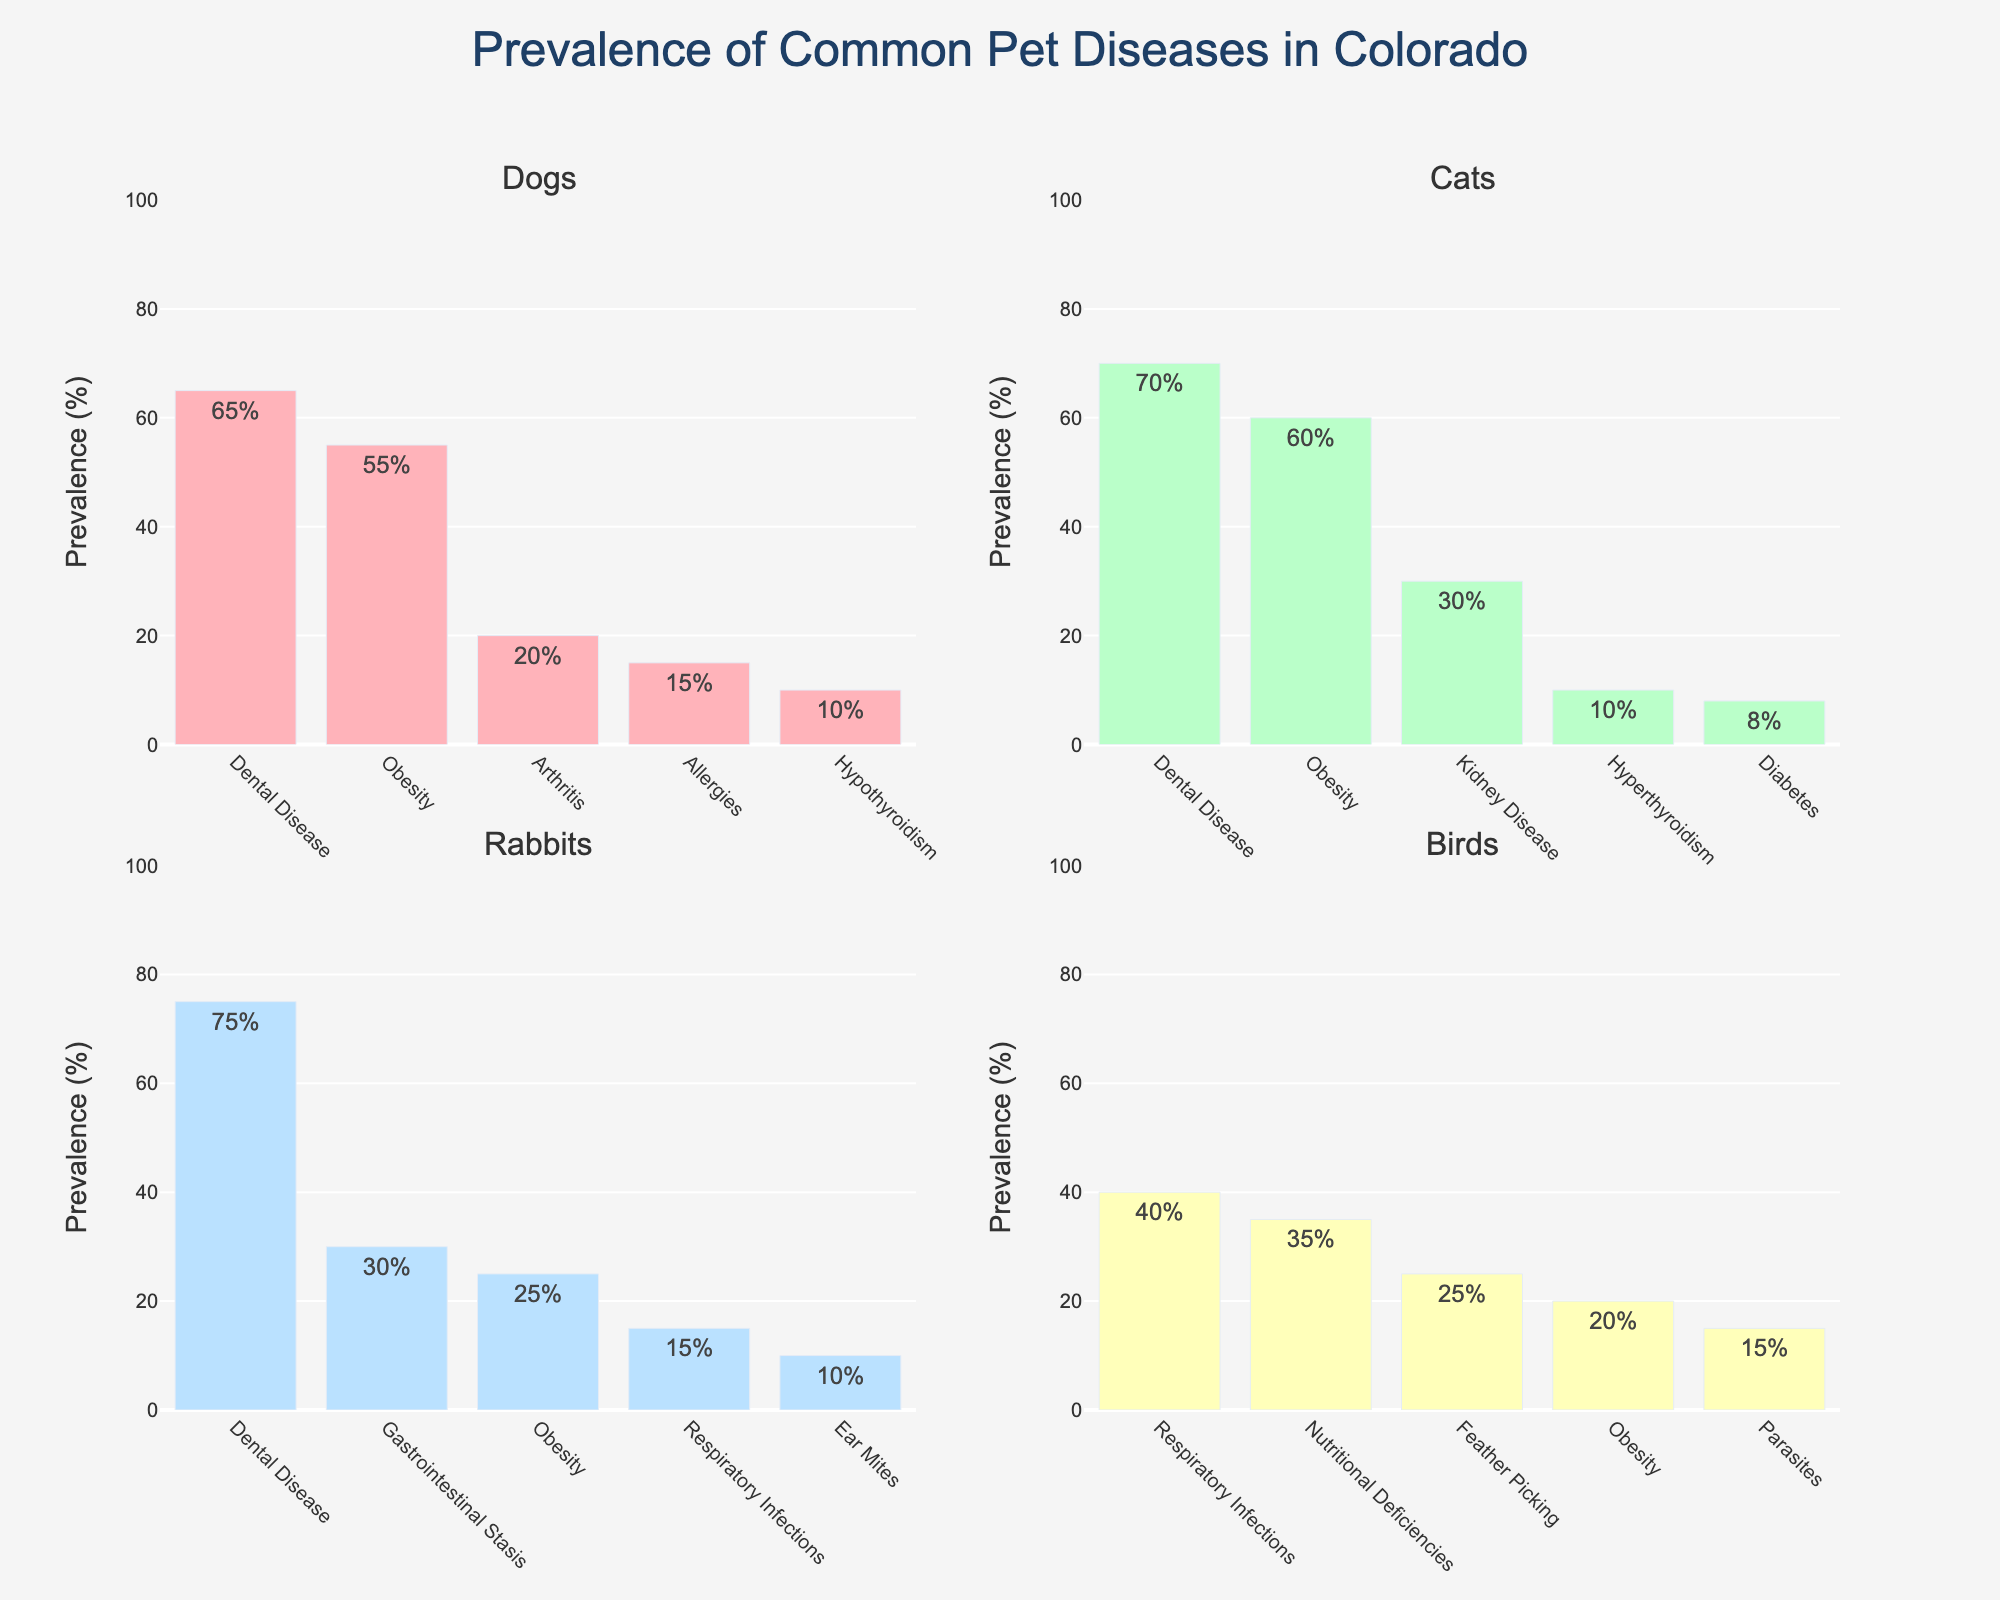Which species has the highest prevalence of dental disease? The figure shows that rabbits have the highest prevalence of dental disease, with a bar reaching up to 75%, which is higher than the 70% in cats, 65% in dogs, and no reported dental disease in birds.
Answer: Rabbits Between dogs and cats, which species has a higher prevalence of obesity? The figure shows that cats have a prevalence of 60% for obesity, while dogs have a prevalence of 55%. Therefore, cats have a higher prevalence of obesity than dogs.
Answer: Cats What is the total combined prevalence of respiratory infections across all species? By examining the figure, the prevalence of respiratory infections is 40% in birds and 15% in rabbits. Summing these values gives 40% + 15% = 55%.
Answer: 55% Which disease has the lowest prevalence among cats, and what is that prevalence? The figure shows that the disease with the lowest prevalence among cats is diabetes, with a prevalence of 8%.
Answer: Diabetes, 8% If we consider the prevalence percentages of arthritis in dogs and ear mites in rabbits, which is higher and by how much? The figure shows that arthritis in dogs has a prevalence of 20%, and ear mites in rabbits have a prevalence of 10%. The difference is 20% - 10% = 10%.
Answer: Arthritis in dogs, by 10% Compare the prevalence of nutritional deficiencies in birds to the prevalence of gastrointestinal stasis in rabbits. Which is higher? The figure indicates that nutritional deficiencies in birds have a prevalence of 35%, while gastrointestinal stasis in rabbits has a prevalence of 30%. Nutritional deficiencies in birds are higher.
Answer: Nutritional deficiencies in birds How does the prevalence of hyperthyroidism in cats compare to hypothyroidism in dogs? Both hyperthyroidism in cats and hypothyroidism in dogs have a prevalence of 10%, so they are equal.
Answer: They are equal What is the average prevalence of the diseases marked for dogs? The prevalence rates for dogs' diseases are 65%, 55%, 20%, 15%, and 10%. Adding these values gives 165%, and the average is 165% ÷ 5 = 33%.
Answer: 33% 